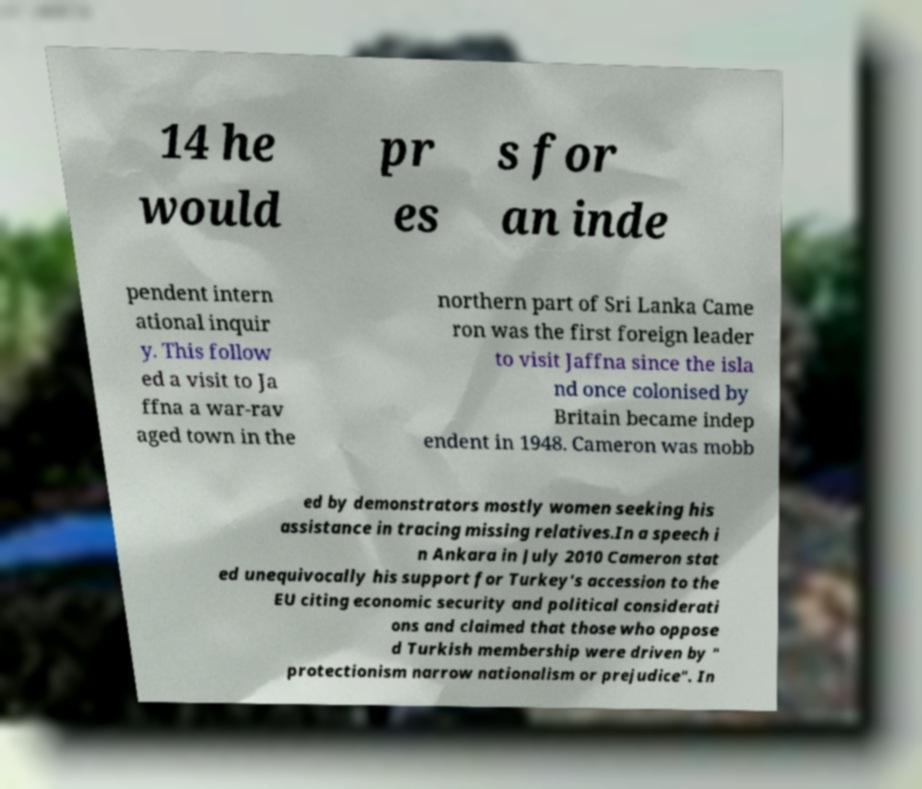For documentation purposes, I need the text within this image transcribed. Could you provide that? 14 he would pr es s for an inde pendent intern ational inquir y. This follow ed a visit to Ja ffna a war-rav aged town in the northern part of Sri Lanka Came ron was the first foreign leader to visit Jaffna since the isla nd once colonised by Britain became indep endent in 1948. Cameron was mobb ed by demonstrators mostly women seeking his assistance in tracing missing relatives.In a speech i n Ankara in July 2010 Cameron stat ed unequivocally his support for Turkey's accession to the EU citing economic security and political considerati ons and claimed that those who oppose d Turkish membership were driven by " protectionism narrow nationalism or prejudice". In 